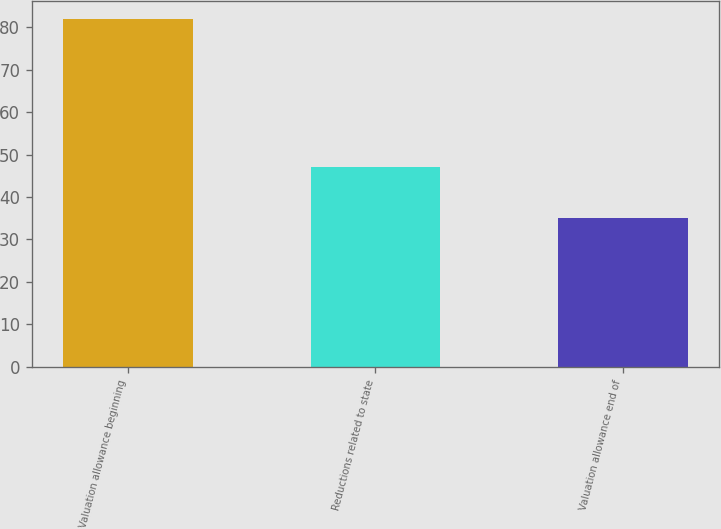<chart> <loc_0><loc_0><loc_500><loc_500><bar_chart><fcel>Valuation allowance beginning<fcel>Reductions related to state<fcel>Valuation allowance end of<nl><fcel>82<fcel>47<fcel>35<nl></chart> 